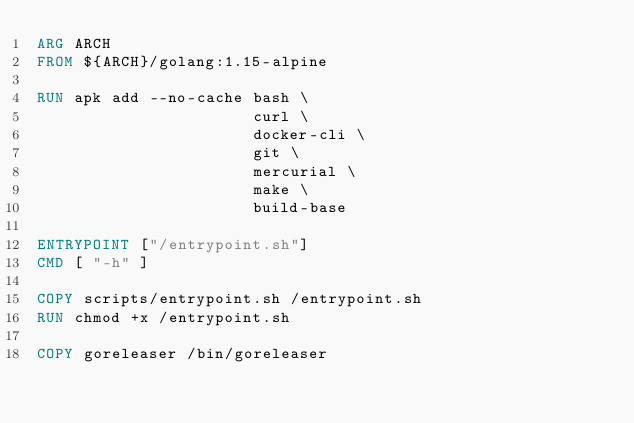<code> <loc_0><loc_0><loc_500><loc_500><_Dockerfile_>ARG ARCH
FROM ${ARCH}/golang:1.15-alpine

RUN apk add --no-cache bash \
                       curl \
                       docker-cli \
                       git \
                       mercurial \
                       make \
                       build-base

ENTRYPOINT ["/entrypoint.sh"]
CMD [ "-h" ]

COPY scripts/entrypoint.sh /entrypoint.sh
RUN chmod +x /entrypoint.sh

COPY goreleaser /bin/goreleaser
</code> 